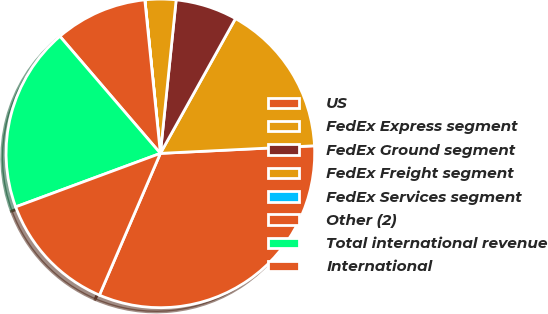Convert chart. <chart><loc_0><loc_0><loc_500><loc_500><pie_chart><fcel>US<fcel>FedEx Express segment<fcel>FedEx Ground segment<fcel>FedEx Freight segment<fcel>FedEx Services segment<fcel>Other (2)<fcel>Total international revenue<fcel>International<nl><fcel>32.25%<fcel>16.13%<fcel>6.46%<fcel>3.23%<fcel>0.01%<fcel>9.68%<fcel>19.35%<fcel>12.9%<nl></chart> 